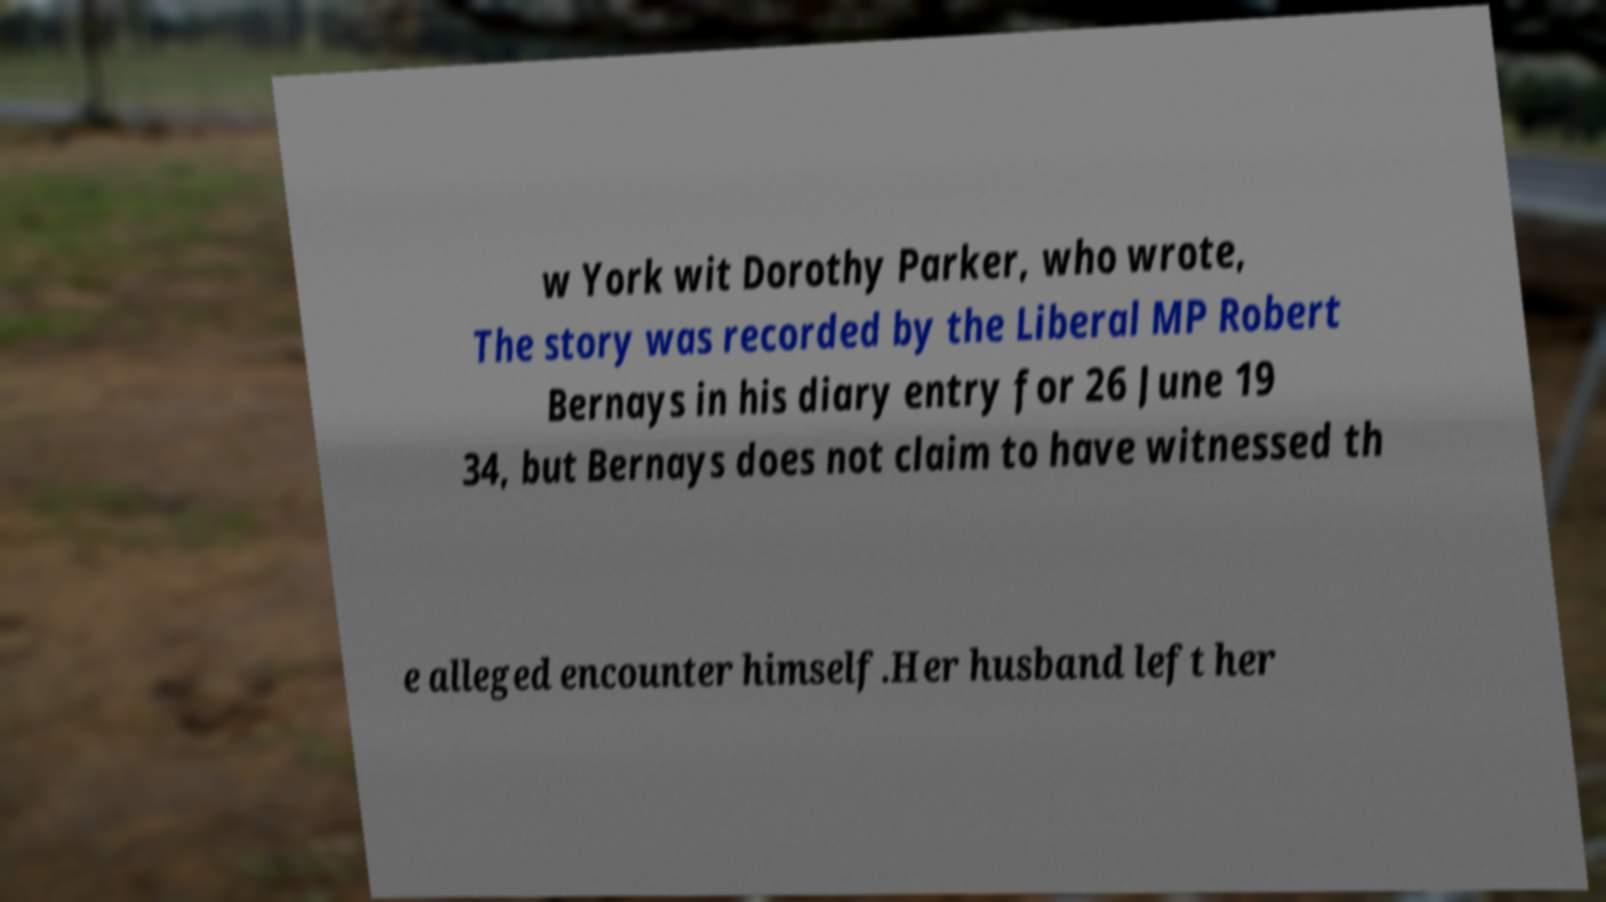Could you extract and type out the text from this image? w York wit Dorothy Parker, who wrote, The story was recorded by the Liberal MP Robert Bernays in his diary entry for 26 June 19 34, but Bernays does not claim to have witnessed th e alleged encounter himself.Her husband left her 